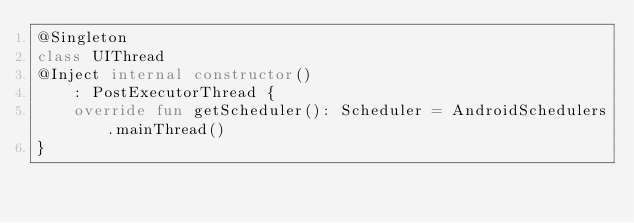<code> <loc_0><loc_0><loc_500><loc_500><_Kotlin_>@Singleton
class UIThread
@Inject internal constructor()
    : PostExecutorThread {
    override fun getScheduler(): Scheduler = AndroidSchedulers.mainThread()
}
</code> 